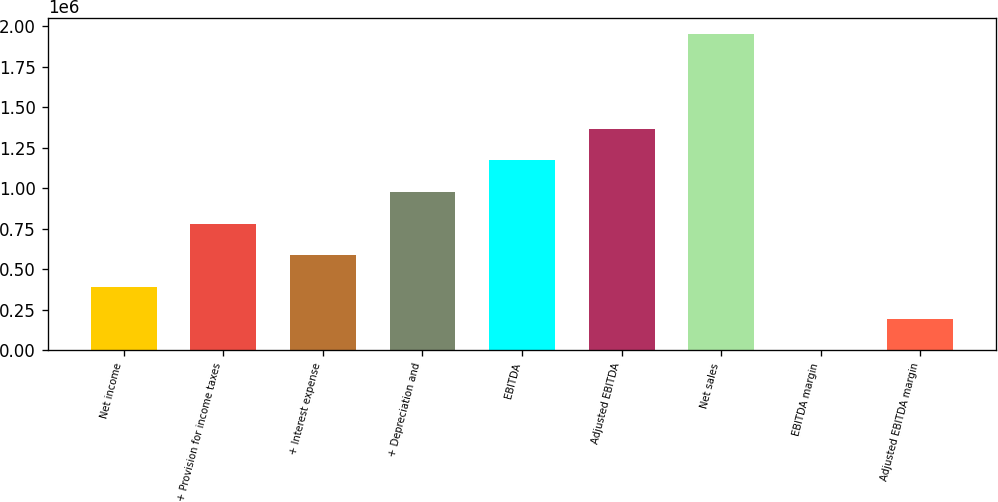Convert chart to OTSL. <chart><loc_0><loc_0><loc_500><loc_500><bar_chart><fcel>Net income<fcel>+ Provision for income taxes<fcel>+ Interest expense<fcel>+ Depreciation and<fcel>EBITDA<fcel>Adjusted EBITDA<fcel>Net sales<fcel>EBITDA margin<fcel>Adjusted EBITDA margin<nl><fcel>390860<fcel>781710<fcel>586285<fcel>977134<fcel>1.17256e+06<fcel>1.36798e+06<fcel>1.95426e+06<fcel>10.6<fcel>195435<nl></chart> 